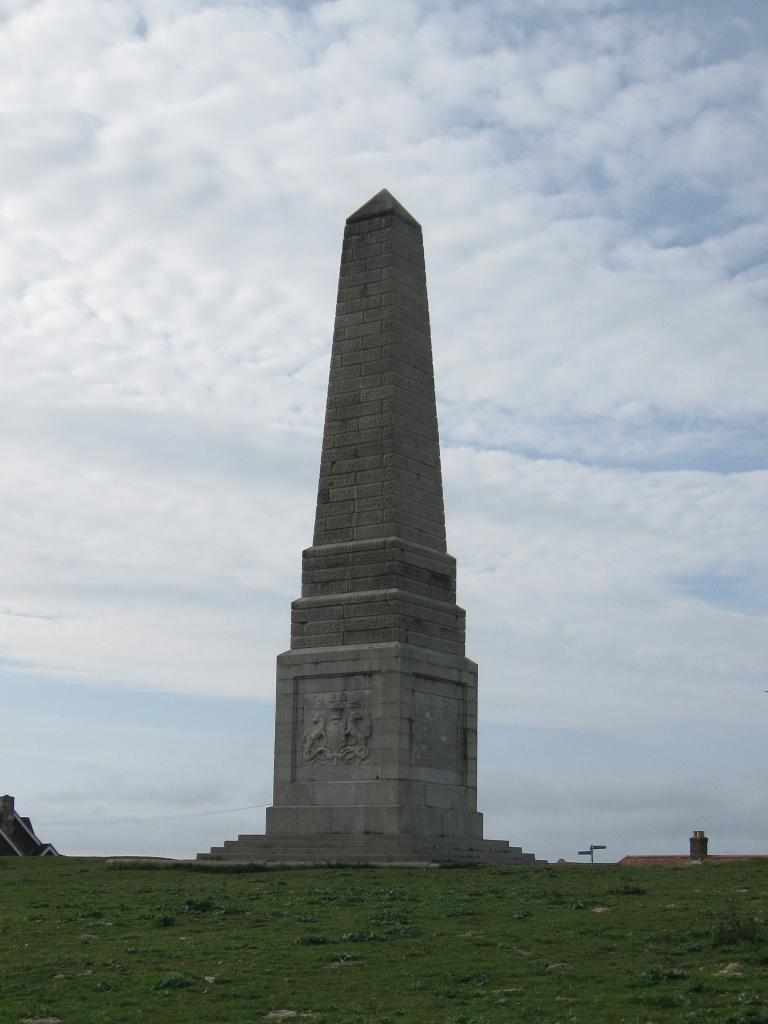What is the main subject of the image? The main subject of the image is a historical pillar. Where is the historical pillar located? The historical pillar is on a grass surface. What can be seen in the background of the image? Sky and clouds are visible in the background of the image. What type of toothpaste is being used to clean the historical pillar in the image? There is no toothpaste present in the image, and the historical pillar is not being cleaned. 